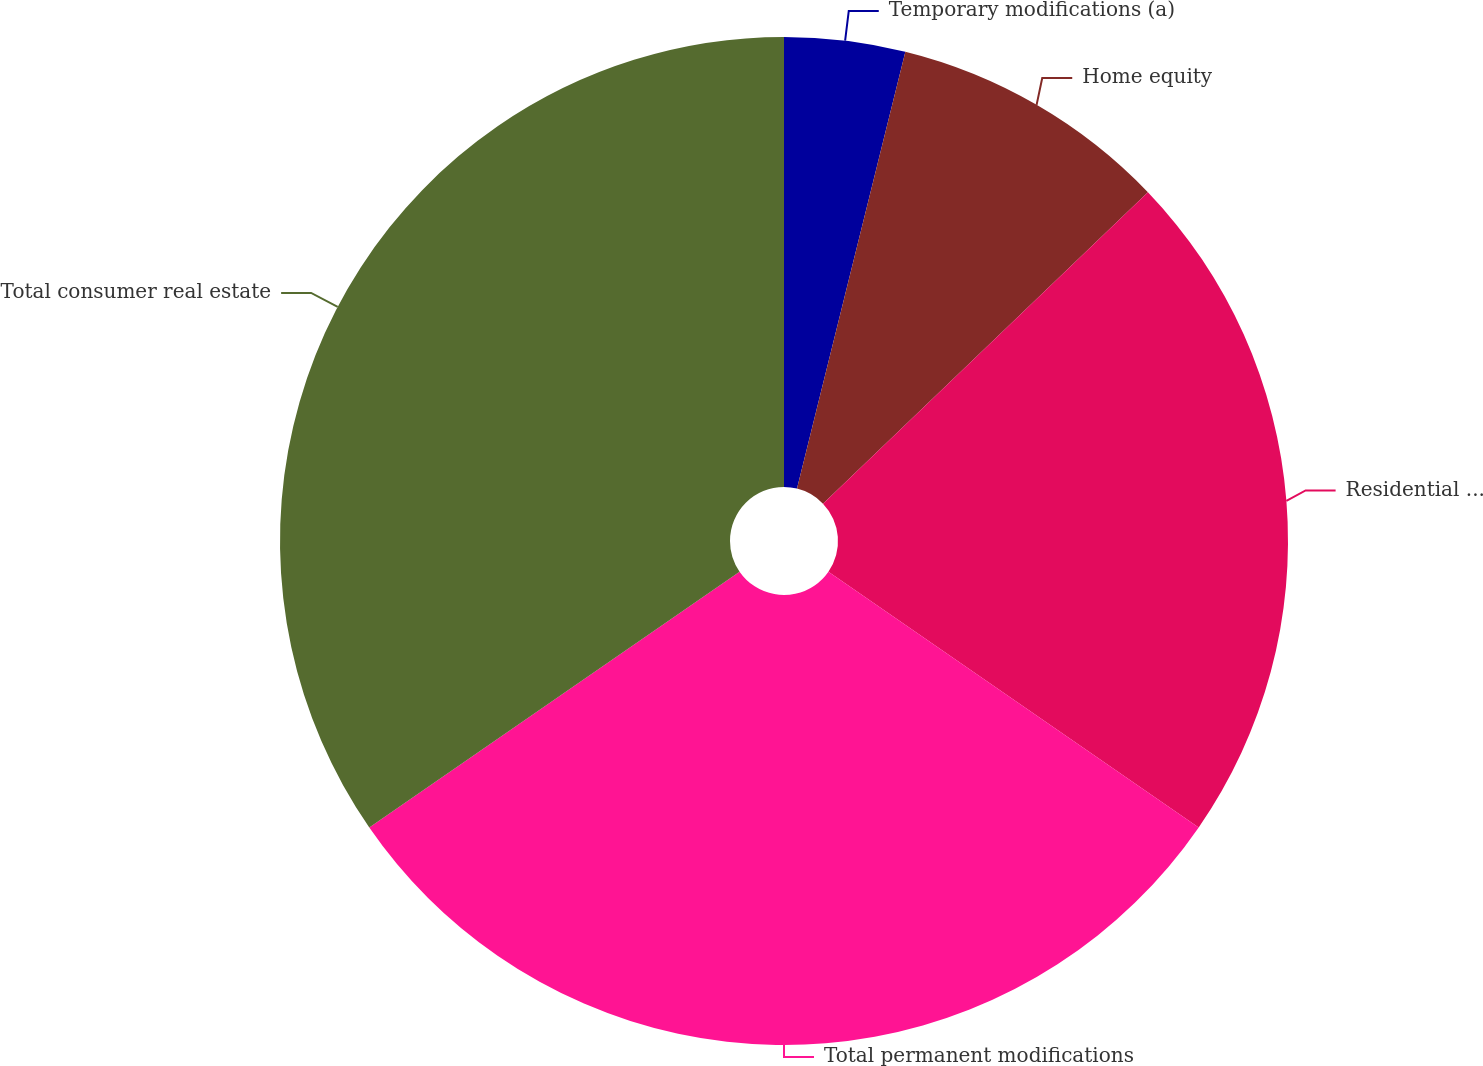Convert chart. <chart><loc_0><loc_0><loc_500><loc_500><pie_chart><fcel>Temporary modifications (a)<fcel>Home equity<fcel>Residential real estate<fcel>Total permanent modifications<fcel>Total consumer real estate<nl><fcel>3.87%<fcel>8.97%<fcel>21.78%<fcel>30.76%<fcel>34.62%<nl></chart> 